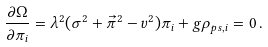<formula> <loc_0><loc_0><loc_500><loc_500>\frac { \partial \Omega } { \partial \pi _ { i } } = \lambda ^ { 2 } ( \sigma ^ { 2 } + \vec { \pi } ^ { 2 } - v ^ { 2 } ) \pi _ { i } + g \rho _ { p s , i } = 0 \, .</formula> 